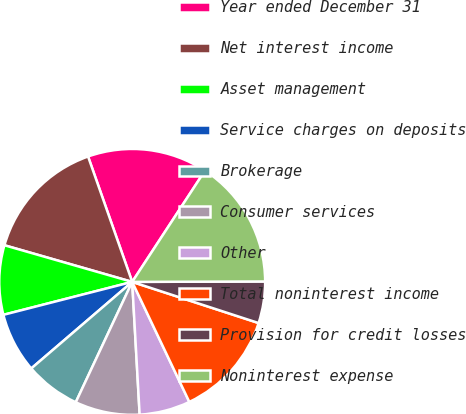Convert chart. <chart><loc_0><loc_0><loc_500><loc_500><pie_chart><fcel>Year ended December 31<fcel>Net interest income<fcel>Asset management<fcel>Service charges on deposits<fcel>Brokerage<fcel>Consumer services<fcel>Other<fcel>Total noninterest income<fcel>Provision for credit losses<fcel>Noninterest expense<nl><fcel>14.61%<fcel>15.17%<fcel>8.43%<fcel>7.3%<fcel>6.74%<fcel>7.87%<fcel>6.18%<fcel>12.92%<fcel>5.06%<fcel>15.73%<nl></chart> 